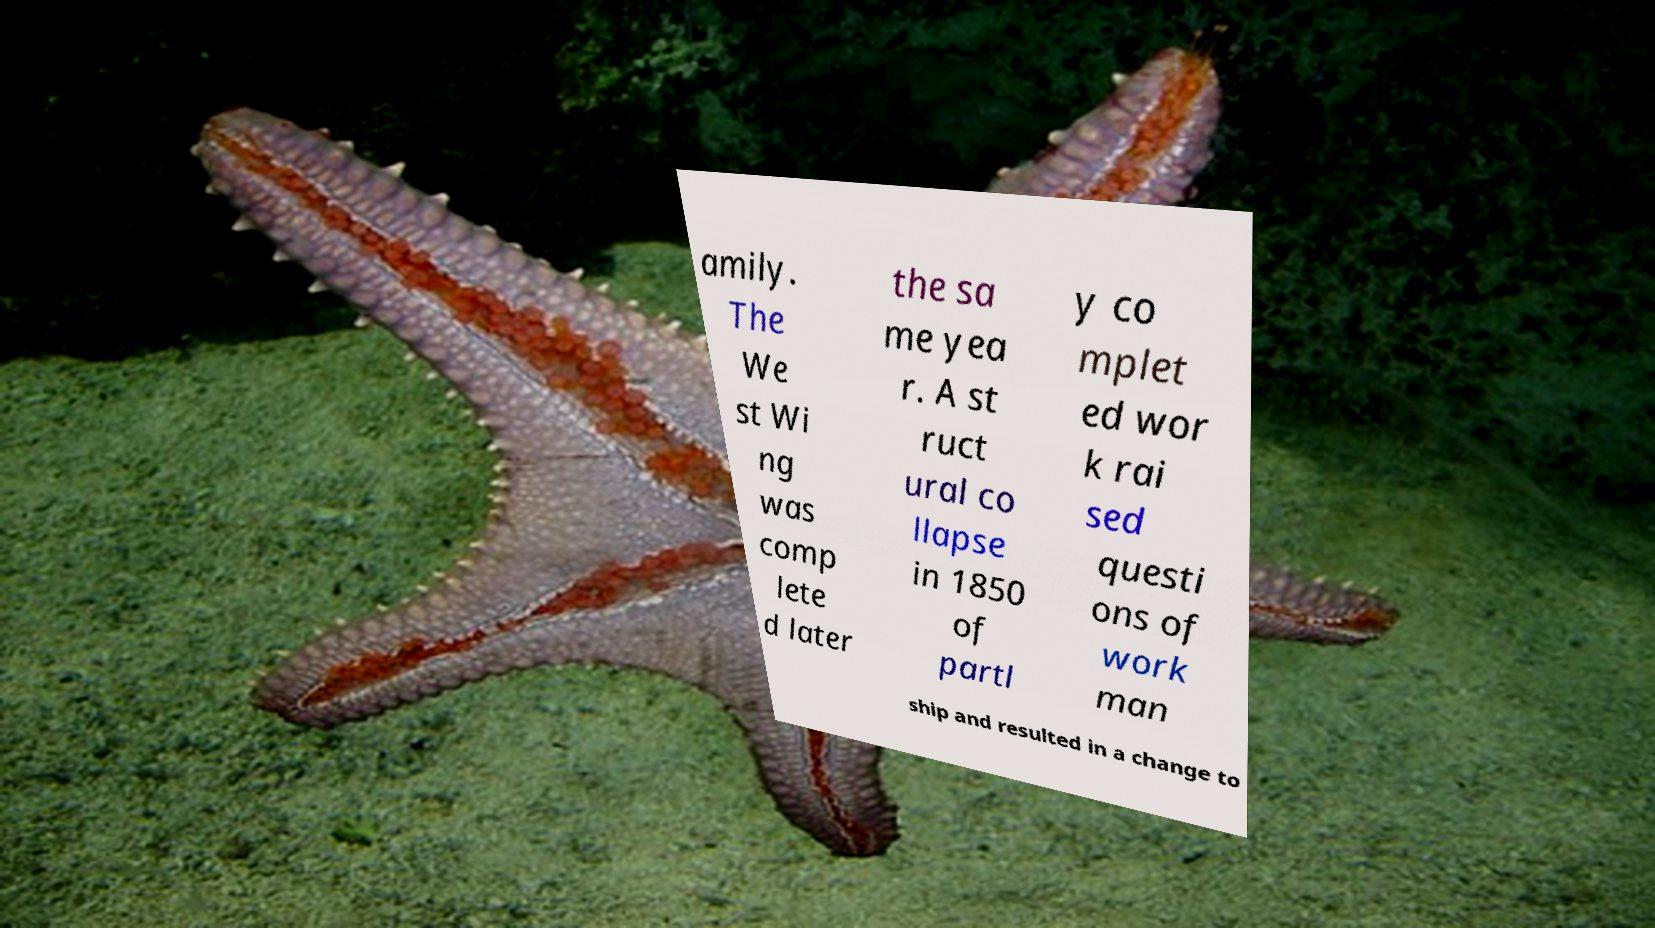Can you accurately transcribe the text from the provided image for me? amily. The We st Wi ng was comp lete d later the sa me yea r. A st ruct ural co llapse in 1850 of partl y co mplet ed wor k rai sed questi ons of work man ship and resulted in a change to 